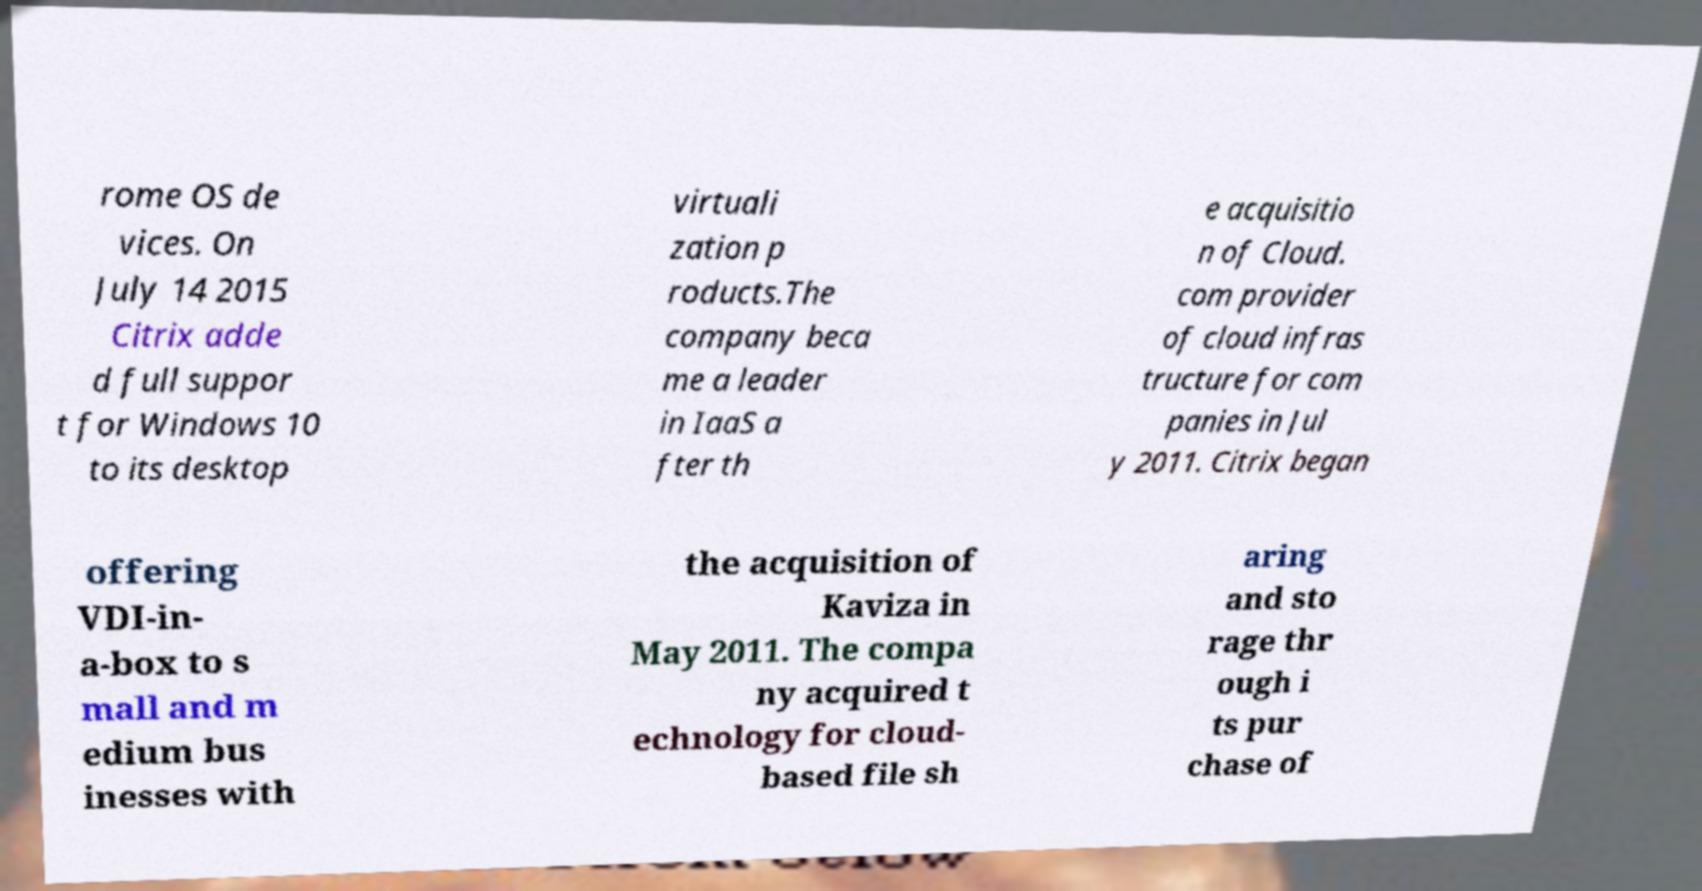What messages or text are displayed in this image? I need them in a readable, typed format. rome OS de vices. On July 14 2015 Citrix adde d full suppor t for Windows 10 to its desktop virtuali zation p roducts.The company beca me a leader in IaaS a fter th e acquisitio n of Cloud. com provider of cloud infras tructure for com panies in Jul y 2011. Citrix began offering VDI-in- a-box to s mall and m edium bus inesses with the acquisition of Kaviza in May 2011. The compa ny acquired t echnology for cloud- based file sh aring and sto rage thr ough i ts pur chase of 